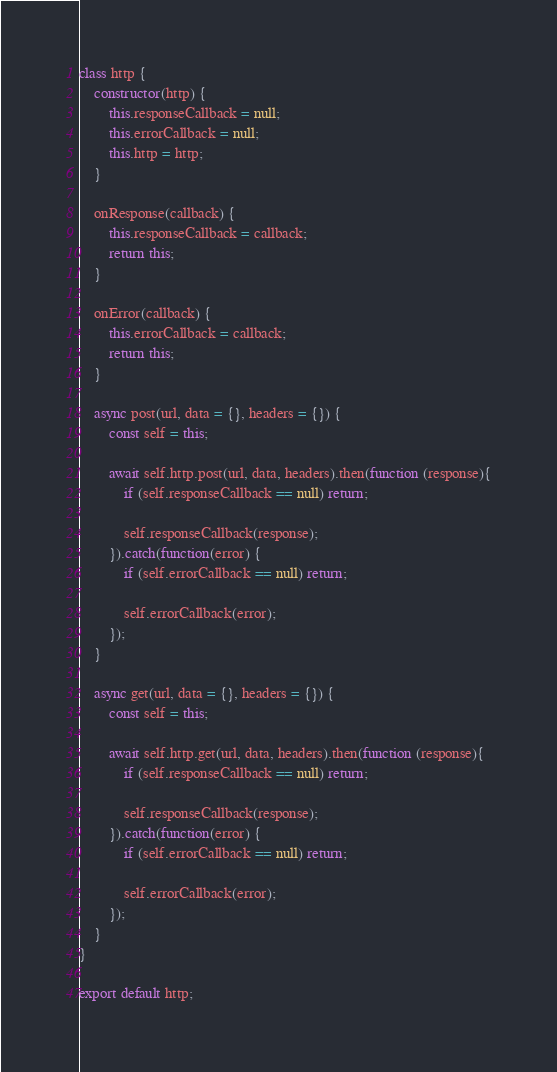Convert code to text. <code><loc_0><loc_0><loc_500><loc_500><_JavaScript_>
class http {
    constructor(http) {
        this.responseCallback = null;
        this.errorCallback = null;
        this.http = http;
    }

    onResponse(callback) {
        this.responseCallback = callback;
        return this;
    }

    onError(callback) {
        this.errorCallback = callback;
        return this;
    }

    async post(url, data = {}, headers = {}) {
        const self = this;

        await self.http.post(url, data, headers).then(function (response){
            if (self.responseCallback == null) return;

            self.responseCallback(response);
        }).catch(function(error) {
            if (self.errorCallback == null) return;

            self.errorCallback(error);
        });
    }

    async get(url, data = {}, headers = {}) {
        const self = this;

        await self.http.get(url, data, headers).then(function (response){
            if (self.responseCallback == null) return;

            self.responseCallback(response);
        }).catch(function(error) {
            if (self.errorCallback == null) return;

            self.errorCallback(error);
        });
    }
}

export default http;
</code> 